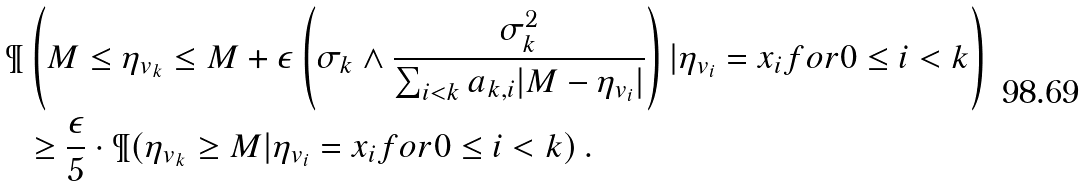Convert formula to latex. <formula><loc_0><loc_0><loc_500><loc_500>\P & \left ( M \leq \eta _ { v _ { k } } \leq M + \epsilon \left ( \sigma _ { k } \wedge \frac { \sigma _ { k } ^ { 2 } } { \sum _ { i < k } a _ { k , i } | M - \eta _ { v _ { i } } | } \right ) | \eta _ { v _ { i } } = x _ { i } f o r 0 \leq i < k \right ) \\ & \geq \frac { \epsilon } { 5 } \cdot \P ( \eta _ { v _ { k } } \geq M | \eta _ { v _ { i } } = x _ { i } f o r 0 \leq i < k ) \, .</formula> 